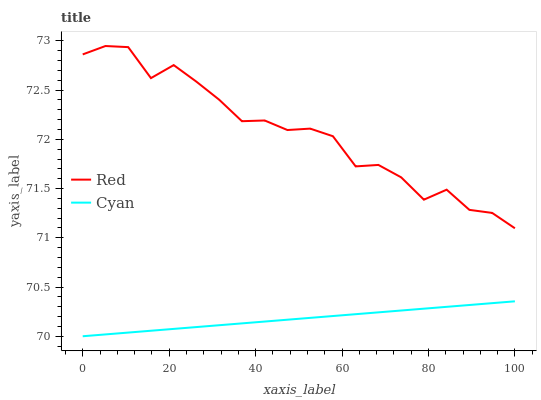Does Cyan have the minimum area under the curve?
Answer yes or no. Yes. Does Red have the maximum area under the curve?
Answer yes or no. Yes. Does Red have the minimum area under the curve?
Answer yes or no. No. Is Cyan the smoothest?
Answer yes or no. Yes. Is Red the roughest?
Answer yes or no. Yes. Is Red the smoothest?
Answer yes or no. No. Does Red have the lowest value?
Answer yes or no. No. Does Red have the highest value?
Answer yes or no. Yes. Is Cyan less than Red?
Answer yes or no. Yes. Is Red greater than Cyan?
Answer yes or no. Yes. Does Cyan intersect Red?
Answer yes or no. No. 